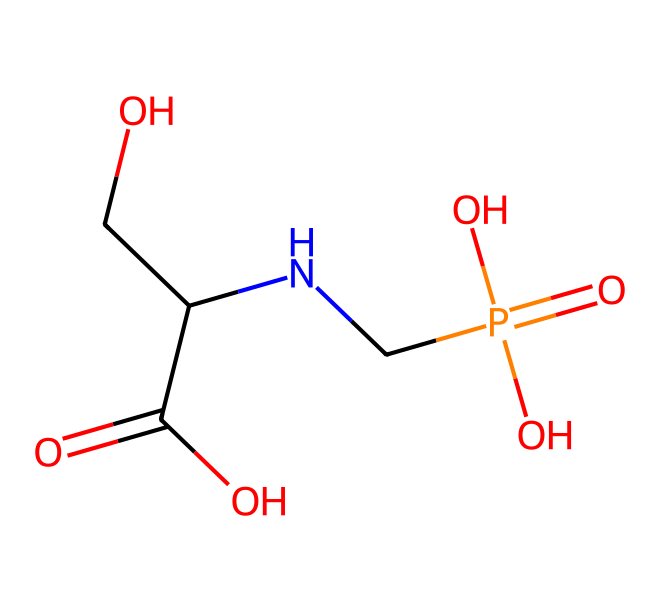What is the primary functional group in glyphosate? The structure shows a carboxylic acid group (-COOH) indicated by the presence of a carbon atom bonded to two oxygen atoms (one with a double bond and one with a hydroxyl group). This is a defining feature of glyphosate's molecular composition.
Answer: carboxylic acid How many carbon atoms are present in glyphosate? By analyzing the chemical structure, we can count the individual carbon atoms, which total to 3 in the given structure (indicated by three central carbon atoms connected to other groups).
Answer: 3 Does glyphosate contain any nitrogen atoms? The visual representation reveals the presence of a nitrogen atom in the structure, linked to a carbon chain and part of an amine group, which confirms that glyphosate contains a nitrogen atom.
Answer: yes What type of chemical is glyphosate classified as? The functional groups and overall structure categorize glyphosate as an herbicide, specifically a systemic herbicide due to its ability to be absorbed and translocated within plants.
Answer: herbicide What is the molecular weight of glyphosate? To determine the molecular weight, one must calculate the contributions of the individual atoms (C, H, N, O) in the SMILES structure and sum them, arriving at a total molecular weight of approximately 169.07 g/mol.
Answer: 169.07 How does the phosphate group in glyphosate affect its function? The phosphate group (-P(O)(O)=O) is crucial for interaction with biochemical pathways in plants, acting to inhibit the shikimic acid pathway, which is essential for the synthesis of certain amino acids.
Answer: inhibits shikimic acid pathway 